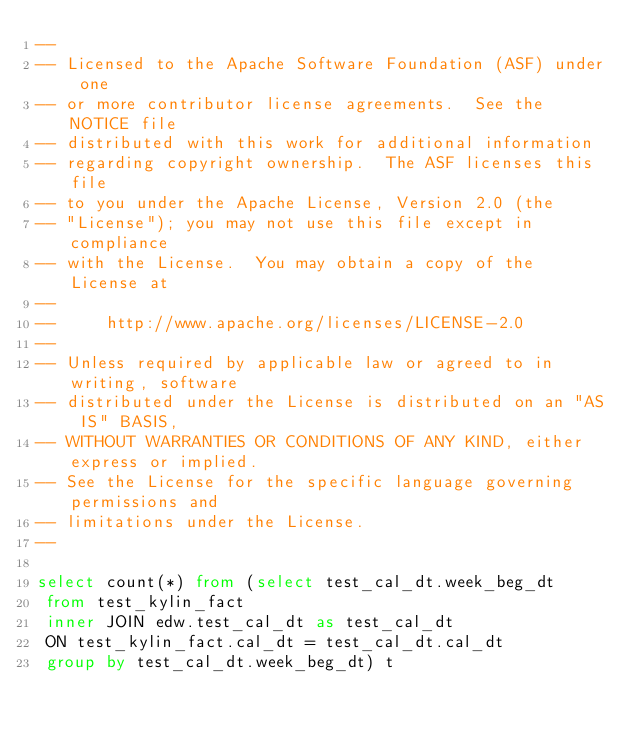<code> <loc_0><loc_0><loc_500><loc_500><_SQL_>--
-- Licensed to the Apache Software Foundation (ASF) under one
-- or more contributor license agreements.  See the NOTICE file
-- distributed with this work for additional information
-- regarding copyright ownership.  The ASF licenses this file
-- to you under the Apache License, Version 2.0 (the
-- "License"); you may not use this file except in compliance
-- with the License.  You may obtain a copy of the License at
--
--     http://www.apache.org/licenses/LICENSE-2.0
--
-- Unless required by applicable law or agreed to in writing, software
-- distributed under the License is distributed on an "AS IS" BASIS,
-- WITHOUT WARRANTIES OR CONDITIONS OF ANY KIND, either express or implied.
-- See the License for the specific language governing permissions and
-- limitations under the License.
--

select count(*) from (select test_cal_dt.week_beg_dt 
 from test_kylin_fact 
 inner JOIN edw.test_cal_dt as test_cal_dt 
 ON test_kylin_fact.cal_dt = test_cal_dt.cal_dt 
 group by test_cal_dt.week_beg_dt) t 
</code> 